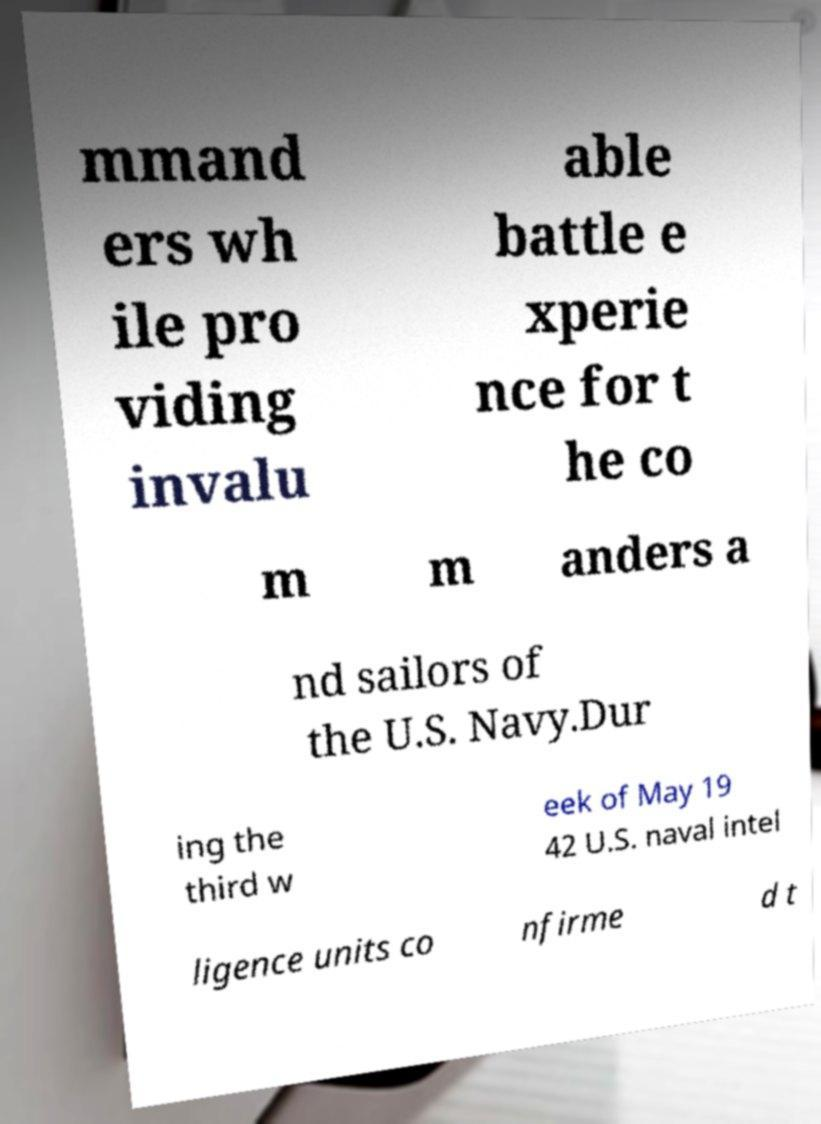Could you assist in decoding the text presented in this image and type it out clearly? mmand ers wh ile pro viding invalu able battle e xperie nce for t he co m m anders a nd sailors of the U.S. Navy.Dur ing the third w eek of May 19 42 U.S. naval intel ligence units co nfirme d t 